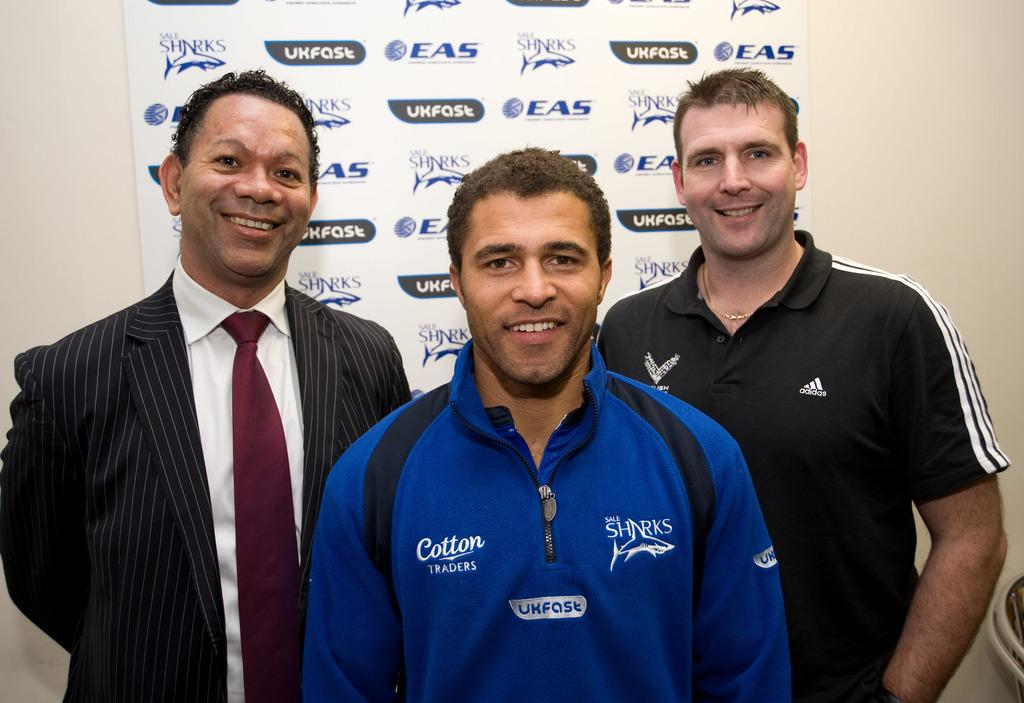<image>
Give a short and clear explanation of the subsequent image. A man with a shirt that says Cotton Traders poses for a photo with two other men. 